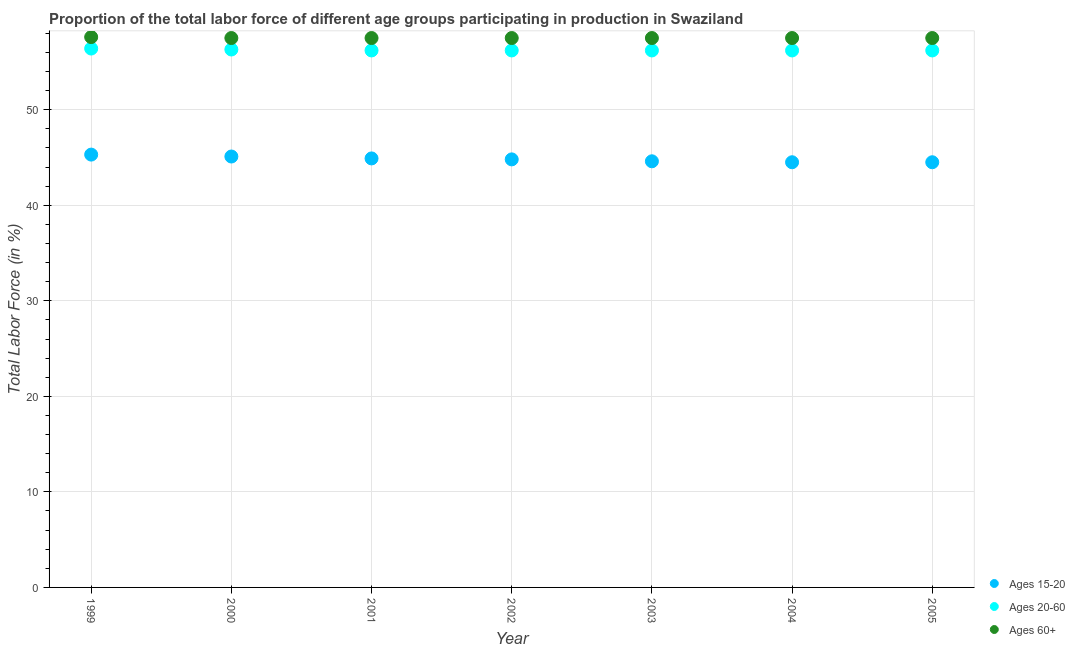Is the number of dotlines equal to the number of legend labels?
Make the answer very short. Yes. What is the percentage of labor force within the age group 20-60 in 2005?
Provide a short and direct response. 56.2. Across all years, what is the maximum percentage of labor force within the age group 20-60?
Make the answer very short. 56.4. Across all years, what is the minimum percentage of labor force above age 60?
Make the answer very short. 57.5. What is the total percentage of labor force within the age group 15-20 in the graph?
Offer a terse response. 313.7. What is the difference between the percentage of labor force within the age group 20-60 in 1999 and that in 2004?
Ensure brevity in your answer.  0.2. What is the difference between the percentage of labor force within the age group 15-20 in 1999 and the percentage of labor force within the age group 20-60 in 2004?
Your response must be concise. -10.9. What is the average percentage of labor force within the age group 20-60 per year?
Offer a terse response. 56.24. In the year 2000, what is the difference between the percentage of labor force within the age group 15-20 and percentage of labor force above age 60?
Offer a terse response. -12.4. What is the ratio of the percentage of labor force within the age group 15-20 in 2003 to that in 2004?
Keep it short and to the point. 1. Is the difference between the percentage of labor force within the age group 15-20 in 2003 and 2005 greater than the difference between the percentage of labor force within the age group 20-60 in 2003 and 2005?
Your response must be concise. Yes. What is the difference between the highest and the second highest percentage of labor force within the age group 15-20?
Make the answer very short. 0.2. What is the difference between the highest and the lowest percentage of labor force within the age group 15-20?
Your answer should be compact. 0.8. Is the sum of the percentage of labor force within the age group 15-20 in 2003 and 2004 greater than the maximum percentage of labor force above age 60 across all years?
Give a very brief answer. Yes. Is it the case that in every year, the sum of the percentage of labor force within the age group 15-20 and percentage of labor force within the age group 20-60 is greater than the percentage of labor force above age 60?
Your answer should be compact. Yes. Does the percentage of labor force within the age group 15-20 monotonically increase over the years?
Your response must be concise. No. Is the percentage of labor force above age 60 strictly greater than the percentage of labor force within the age group 15-20 over the years?
Offer a very short reply. Yes. How many dotlines are there?
Provide a short and direct response. 3. What is the difference between two consecutive major ticks on the Y-axis?
Offer a very short reply. 10. Are the values on the major ticks of Y-axis written in scientific E-notation?
Offer a very short reply. No. Does the graph contain any zero values?
Your answer should be compact. No. Where does the legend appear in the graph?
Offer a very short reply. Bottom right. What is the title of the graph?
Your answer should be compact. Proportion of the total labor force of different age groups participating in production in Swaziland. Does "Oil" appear as one of the legend labels in the graph?
Make the answer very short. No. What is the label or title of the Y-axis?
Ensure brevity in your answer.  Total Labor Force (in %). What is the Total Labor Force (in %) of Ages 15-20 in 1999?
Your answer should be compact. 45.3. What is the Total Labor Force (in %) of Ages 20-60 in 1999?
Offer a terse response. 56.4. What is the Total Labor Force (in %) of Ages 60+ in 1999?
Your answer should be very brief. 57.6. What is the Total Labor Force (in %) of Ages 15-20 in 2000?
Your response must be concise. 45.1. What is the Total Labor Force (in %) in Ages 20-60 in 2000?
Your answer should be very brief. 56.3. What is the Total Labor Force (in %) in Ages 60+ in 2000?
Ensure brevity in your answer.  57.5. What is the Total Labor Force (in %) of Ages 15-20 in 2001?
Provide a short and direct response. 44.9. What is the Total Labor Force (in %) in Ages 20-60 in 2001?
Give a very brief answer. 56.2. What is the Total Labor Force (in %) in Ages 60+ in 2001?
Give a very brief answer. 57.5. What is the Total Labor Force (in %) of Ages 15-20 in 2002?
Provide a succinct answer. 44.8. What is the Total Labor Force (in %) in Ages 20-60 in 2002?
Provide a short and direct response. 56.2. What is the Total Labor Force (in %) in Ages 60+ in 2002?
Make the answer very short. 57.5. What is the Total Labor Force (in %) in Ages 15-20 in 2003?
Provide a succinct answer. 44.6. What is the Total Labor Force (in %) of Ages 20-60 in 2003?
Your response must be concise. 56.2. What is the Total Labor Force (in %) of Ages 60+ in 2003?
Provide a succinct answer. 57.5. What is the Total Labor Force (in %) of Ages 15-20 in 2004?
Give a very brief answer. 44.5. What is the Total Labor Force (in %) of Ages 20-60 in 2004?
Keep it short and to the point. 56.2. What is the Total Labor Force (in %) of Ages 60+ in 2004?
Give a very brief answer. 57.5. What is the Total Labor Force (in %) in Ages 15-20 in 2005?
Your answer should be compact. 44.5. What is the Total Labor Force (in %) of Ages 20-60 in 2005?
Your response must be concise. 56.2. What is the Total Labor Force (in %) in Ages 60+ in 2005?
Ensure brevity in your answer.  57.5. Across all years, what is the maximum Total Labor Force (in %) in Ages 15-20?
Give a very brief answer. 45.3. Across all years, what is the maximum Total Labor Force (in %) in Ages 20-60?
Your answer should be compact. 56.4. Across all years, what is the maximum Total Labor Force (in %) in Ages 60+?
Provide a succinct answer. 57.6. Across all years, what is the minimum Total Labor Force (in %) in Ages 15-20?
Offer a terse response. 44.5. Across all years, what is the minimum Total Labor Force (in %) in Ages 20-60?
Give a very brief answer. 56.2. Across all years, what is the minimum Total Labor Force (in %) in Ages 60+?
Offer a very short reply. 57.5. What is the total Total Labor Force (in %) of Ages 15-20 in the graph?
Make the answer very short. 313.7. What is the total Total Labor Force (in %) in Ages 20-60 in the graph?
Offer a terse response. 393.7. What is the total Total Labor Force (in %) of Ages 60+ in the graph?
Your answer should be very brief. 402.6. What is the difference between the Total Labor Force (in %) in Ages 15-20 in 1999 and that in 2000?
Make the answer very short. 0.2. What is the difference between the Total Labor Force (in %) of Ages 15-20 in 1999 and that in 2001?
Your response must be concise. 0.4. What is the difference between the Total Labor Force (in %) of Ages 20-60 in 1999 and that in 2001?
Keep it short and to the point. 0.2. What is the difference between the Total Labor Force (in %) in Ages 60+ in 1999 and that in 2001?
Provide a short and direct response. 0.1. What is the difference between the Total Labor Force (in %) in Ages 20-60 in 1999 and that in 2002?
Offer a terse response. 0.2. What is the difference between the Total Labor Force (in %) in Ages 60+ in 1999 and that in 2002?
Provide a short and direct response. 0.1. What is the difference between the Total Labor Force (in %) in Ages 15-20 in 1999 and that in 2005?
Ensure brevity in your answer.  0.8. What is the difference between the Total Labor Force (in %) in Ages 60+ in 1999 and that in 2005?
Offer a terse response. 0.1. What is the difference between the Total Labor Force (in %) of Ages 60+ in 2000 and that in 2001?
Offer a very short reply. 0. What is the difference between the Total Labor Force (in %) of Ages 15-20 in 2000 and that in 2002?
Offer a terse response. 0.3. What is the difference between the Total Labor Force (in %) of Ages 60+ in 2000 and that in 2002?
Provide a short and direct response. 0. What is the difference between the Total Labor Force (in %) in Ages 20-60 in 2000 and that in 2003?
Your answer should be compact. 0.1. What is the difference between the Total Labor Force (in %) in Ages 60+ in 2000 and that in 2004?
Provide a succinct answer. 0. What is the difference between the Total Labor Force (in %) in Ages 15-20 in 2000 and that in 2005?
Ensure brevity in your answer.  0.6. What is the difference between the Total Labor Force (in %) of Ages 60+ in 2001 and that in 2002?
Provide a succinct answer. 0. What is the difference between the Total Labor Force (in %) in Ages 60+ in 2001 and that in 2003?
Provide a short and direct response. 0. What is the difference between the Total Labor Force (in %) of Ages 15-20 in 2001 and that in 2004?
Make the answer very short. 0.4. What is the difference between the Total Labor Force (in %) of Ages 20-60 in 2001 and that in 2004?
Ensure brevity in your answer.  0. What is the difference between the Total Labor Force (in %) of Ages 60+ in 2001 and that in 2004?
Provide a short and direct response. 0. What is the difference between the Total Labor Force (in %) of Ages 15-20 in 2001 and that in 2005?
Keep it short and to the point. 0.4. What is the difference between the Total Labor Force (in %) in Ages 60+ in 2001 and that in 2005?
Make the answer very short. 0. What is the difference between the Total Labor Force (in %) in Ages 15-20 in 2002 and that in 2003?
Give a very brief answer. 0.2. What is the difference between the Total Labor Force (in %) in Ages 60+ in 2002 and that in 2003?
Keep it short and to the point. 0. What is the difference between the Total Labor Force (in %) in Ages 15-20 in 2002 and that in 2004?
Offer a very short reply. 0.3. What is the difference between the Total Labor Force (in %) in Ages 60+ in 2002 and that in 2004?
Provide a succinct answer. 0. What is the difference between the Total Labor Force (in %) in Ages 15-20 in 2002 and that in 2005?
Give a very brief answer. 0.3. What is the difference between the Total Labor Force (in %) in Ages 20-60 in 2002 and that in 2005?
Provide a succinct answer. 0. What is the difference between the Total Labor Force (in %) of Ages 15-20 in 2003 and that in 2005?
Keep it short and to the point. 0.1. What is the difference between the Total Labor Force (in %) of Ages 60+ in 2003 and that in 2005?
Ensure brevity in your answer.  0. What is the difference between the Total Labor Force (in %) in Ages 15-20 in 2004 and that in 2005?
Ensure brevity in your answer.  0. What is the difference between the Total Labor Force (in %) of Ages 60+ in 2004 and that in 2005?
Your answer should be compact. 0. What is the difference between the Total Labor Force (in %) in Ages 15-20 in 1999 and the Total Labor Force (in %) in Ages 20-60 in 2001?
Make the answer very short. -10.9. What is the difference between the Total Labor Force (in %) in Ages 15-20 in 1999 and the Total Labor Force (in %) in Ages 60+ in 2001?
Give a very brief answer. -12.2. What is the difference between the Total Labor Force (in %) in Ages 20-60 in 1999 and the Total Labor Force (in %) in Ages 60+ in 2001?
Your response must be concise. -1.1. What is the difference between the Total Labor Force (in %) in Ages 15-20 in 1999 and the Total Labor Force (in %) in Ages 60+ in 2002?
Ensure brevity in your answer.  -12.2. What is the difference between the Total Labor Force (in %) of Ages 20-60 in 1999 and the Total Labor Force (in %) of Ages 60+ in 2002?
Make the answer very short. -1.1. What is the difference between the Total Labor Force (in %) of Ages 15-20 in 1999 and the Total Labor Force (in %) of Ages 20-60 in 2003?
Provide a short and direct response. -10.9. What is the difference between the Total Labor Force (in %) in Ages 15-20 in 1999 and the Total Labor Force (in %) in Ages 20-60 in 2004?
Give a very brief answer. -10.9. What is the difference between the Total Labor Force (in %) in Ages 20-60 in 1999 and the Total Labor Force (in %) in Ages 60+ in 2004?
Your response must be concise. -1.1. What is the difference between the Total Labor Force (in %) of Ages 20-60 in 1999 and the Total Labor Force (in %) of Ages 60+ in 2005?
Keep it short and to the point. -1.1. What is the difference between the Total Labor Force (in %) in Ages 15-20 in 2000 and the Total Labor Force (in %) in Ages 60+ in 2001?
Make the answer very short. -12.4. What is the difference between the Total Labor Force (in %) of Ages 20-60 in 2000 and the Total Labor Force (in %) of Ages 60+ in 2001?
Keep it short and to the point. -1.2. What is the difference between the Total Labor Force (in %) in Ages 20-60 in 2000 and the Total Labor Force (in %) in Ages 60+ in 2002?
Make the answer very short. -1.2. What is the difference between the Total Labor Force (in %) of Ages 15-20 in 2000 and the Total Labor Force (in %) of Ages 20-60 in 2003?
Your answer should be compact. -11.1. What is the difference between the Total Labor Force (in %) in Ages 20-60 in 2000 and the Total Labor Force (in %) in Ages 60+ in 2004?
Give a very brief answer. -1.2. What is the difference between the Total Labor Force (in %) in Ages 15-20 in 2000 and the Total Labor Force (in %) in Ages 60+ in 2005?
Your answer should be very brief. -12.4. What is the difference between the Total Labor Force (in %) in Ages 20-60 in 2000 and the Total Labor Force (in %) in Ages 60+ in 2005?
Provide a succinct answer. -1.2. What is the difference between the Total Labor Force (in %) of Ages 15-20 in 2001 and the Total Labor Force (in %) of Ages 20-60 in 2002?
Provide a succinct answer. -11.3. What is the difference between the Total Labor Force (in %) in Ages 15-20 in 2001 and the Total Labor Force (in %) in Ages 20-60 in 2003?
Keep it short and to the point. -11.3. What is the difference between the Total Labor Force (in %) in Ages 20-60 in 2001 and the Total Labor Force (in %) in Ages 60+ in 2003?
Give a very brief answer. -1.3. What is the difference between the Total Labor Force (in %) in Ages 15-20 in 2001 and the Total Labor Force (in %) in Ages 60+ in 2004?
Provide a succinct answer. -12.6. What is the difference between the Total Labor Force (in %) of Ages 15-20 in 2001 and the Total Labor Force (in %) of Ages 20-60 in 2005?
Make the answer very short. -11.3. What is the difference between the Total Labor Force (in %) in Ages 20-60 in 2001 and the Total Labor Force (in %) in Ages 60+ in 2005?
Your answer should be very brief. -1.3. What is the difference between the Total Labor Force (in %) of Ages 15-20 in 2002 and the Total Labor Force (in %) of Ages 20-60 in 2003?
Your answer should be compact. -11.4. What is the difference between the Total Labor Force (in %) of Ages 15-20 in 2002 and the Total Labor Force (in %) of Ages 60+ in 2003?
Offer a very short reply. -12.7. What is the difference between the Total Labor Force (in %) of Ages 20-60 in 2002 and the Total Labor Force (in %) of Ages 60+ in 2003?
Your answer should be compact. -1.3. What is the difference between the Total Labor Force (in %) of Ages 15-20 in 2002 and the Total Labor Force (in %) of Ages 20-60 in 2005?
Ensure brevity in your answer.  -11.4. What is the difference between the Total Labor Force (in %) in Ages 15-20 in 2002 and the Total Labor Force (in %) in Ages 60+ in 2005?
Offer a very short reply. -12.7. What is the difference between the Total Labor Force (in %) of Ages 20-60 in 2002 and the Total Labor Force (in %) of Ages 60+ in 2005?
Offer a very short reply. -1.3. What is the difference between the Total Labor Force (in %) in Ages 15-20 in 2003 and the Total Labor Force (in %) in Ages 60+ in 2004?
Your answer should be compact. -12.9. What is the difference between the Total Labor Force (in %) of Ages 20-60 in 2003 and the Total Labor Force (in %) of Ages 60+ in 2004?
Provide a succinct answer. -1.3. What is the difference between the Total Labor Force (in %) of Ages 20-60 in 2003 and the Total Labor Force (in %) of Ages 60+ in 2005?
Make the answer very short. -1.3. What is the difference between the Total Labor Force (in %) in Ages 15-20 in 2004 and the Total Labor Force (in %) in Ages 60+ in 2005?
Provide a succinct answer. -13. What is the average Total Labor Force (in %) in Ages 15-20 per year?
Give a very brief answer. 44.81. What is the average Total Labor Force (in %) of Ages 20-60 per year?
Ensure brevity in your answer.  56.24. What is the average Total Labor Force (in %) of Ages 60+ per year?
Give a very brief answer. 57.51. In the year 1999, what is the difference between the Total Labor Force (in %) of Ages 15-20 and Total Labor Force (in %) of Ages 60+?
Offer a very short reply. -12.3. In the year 2000, what is the difference between the Total Labor Force (in %) of Ages 20-60 and Total Labor Force (in %) of Ages 60+?
Ensure brevity in your answer.  -1.2. In the year 2001, what is the difference between the Total Labor Force (in %) of Ages 15-20 and Total Labor Force (in %) of Ages 20-60?
Your answer should be very brief. -11.3. In the year 2001, what is the difference between the Total Labor Force (in %) in Ages 15-20 and Total Labor Force (in %) in Ages 60+?
Your answer should be compact. -12.6. In the year 2003, what is the difference between the Total Labor Force (in %) in Ages 15-20 and Total Labor Force (in %) in Ages 20-60?
Make the answer very short. -11.6. In the year 2003, what is the difference between the Total Labor Force (in %) of Ages 20-60 and Total Labor Force (in %) of Ages 60+?
Keep it short and to the point. -1.3. In the year 2004, what is the difference between the Total Labor Force (in %) in Ages 15-20 and Total Labor Force (in %) in Ages 20-60?
Your answer should be compact. -11.7. In the year 2004, what is the difference between the Total Labor Force (in %) of Ages 15-20 and Total Labor Force (in %) of Ages 60+?
Provide a succinct answer. -13. In the year 2005, what is the difference between the Total Labor Force (in %) of Ages 15-20 and Total Labor Force (in %) of Ages 60+?
Offer a terse response. -13. What is the ratio of the Total Labor Force (in %) of Ages 15-20 in 1999 to that in 2000?
Make the answer very short. 1. What is the ratio of the Total Labor Force (in %) of Ages 60+ in 1999 to that in 2000?
Your answer should be very brief. 1. What is the ratio of the Total Labor Force (in %) of Ages 15-20 in 1999 to that in 2001?
Keep it short and to the point. 1.01. What is the ratio of the Total Labor Force (in %) of Ages 60+ in 1999 to that in 2001?
Ensure brevity in your answer.  1. What is the ratio of the Total Labor Force (in %) of Ages 15-20 in 1999 to that in 2002?
Your answer should be compact. 1.01. What is the ratio of the Total Labor Force (in %) of Ages 15-20 in 1999 to that in 2003?
Give a very brief answer. 1.02. What is the ratio of the Total Labor Force (in %) of Ages 60+ in 1999 to that in 2004?
Give a very brief answer. 1. What is the ratio of the Total Labor Force (in %) of Ages 15-20 in 1999 to that in 2005?
Your answer should be very brief. 1.02. What is the ratio of the Total Labor Force (in %) in Ages 15-20 in 2000 to that in 2001?
Ensure brevity in your answer.  1. What is the ratio of the Total Labor Force (in %) of Ages 15-20 in 2000 to that in 2002?
Make the answer very short. 1.01. What is the ratio of the Total Labor Force (in %) in Ages 15-20 in 2000 to that in 2003?
Provide a short and direct response. 1.01. What is the ratio of the Total Labor Force (in %) of Ages 15-20 in 2000 to that in 2004?
Your response must be concise. 1.01. What is the ratio of the Total Labor Force (in %) of Ages 20-60 in 2000 to that in 2004?
Keep it short and to the point. 1. What is the ratio of the Total Labor Force (in %) in Ages 60+ in 2000 to that in 2004?
Make the answer very short. 1. What is the ratio of the Total Labor Force (in %) of Ages 15-20 in 2000 to that in 2005?
Ensure brevity in your answer.  1.01. What is the ratio of the Total Labor Force (in %) in Ages 20-60 in 2000 to that in 2005?
Make the answer very short. 1. What is the ratio of the Total Labor Force (in %) of Ages 60+ in 2000 to that in 2005?
Your answer should be compact. 1. What is the ratio of the Total Labor Force (in %) in Ages 20-60 in 2001 to that in 2002?
Make the answer very short. 1. What is the ratio of the Total Labor Force (in %) of Ages 15-20 in 2001 to that in 2004?
Provide a short and direct response. 1.01. What is the ratio of the Total Labor Force (in %) of Ages 60+ in 2001 to that in 2004?
Ensure brevity in your answer.  1. What is the ratio of the Total Labor Force (in %) of Ages 15-20 in 2001 to that in 2005?
Give a very brief answer. 1.01. What is the ratio of the Total Labor Force (in %) in Ages 20-60 in 2001 to that in 2005?
Provide a succinct answer. 1. What is the ratio of the Total Labor Force (in %) of Ages 60+ in 2001 to that in 2005?
Your answer should be very brief. 1. What is the ratio of the Total Labor Force (in %) in Ages 15-20 in 2002 to that in 2003?
Provide a succinct answer. 1. What is the ratio of the Total Labor Force (in %) in Ages 15-20 in 2002 to that in 2004?
Offer a very short reply. 1.01. What is the ratio of the Total Labor Force (in %) in Ages 15-20 in 2002 to that in 2005?
Keep it short and to the point. 1.01. What is the ratio of the Total Labor Force (in %) of Ages 20-60 in 2002 to that in 2005?
Give a very brief answer. 1. What is the ratio of the Total Labor Force (in %) in Ages 60+ in 2002 to that in 2005?
Keep it short and to the point. 1. What is the ratio of the Total Labor Force (in %) in Ages 15-20 in 2003 to that in 2004?
Your response must be concise. 1. What is the ratio of the Total Labor Force (in %) of Ages 60+ in 2003 to that in 2005?
Give a very brief answer. 1. What is the ratio of the Total Labor Force (in %) of Ages 15-20 in 2004 to that in 2005?
Provide a succinct answer. 1. What is the ratio of the Total Labor Force (in %) of Ages 60+ in 2004 to that in 2005?
Your response must be concise. 1. What is the difference between the highest and the second highest Total Labor Force (in %) of Ages 15-20?
Provide a succinct answer. 0.2. What is the difference between the highest and the second highest Total Labor Force (in %) in Ages 60+?
Give a very brief answer. 0.1. What is the difference between the highest and the lowest Total Labor Force (in %) in Ages 15-20?
Ensure brevity in your answer.  0.8. 